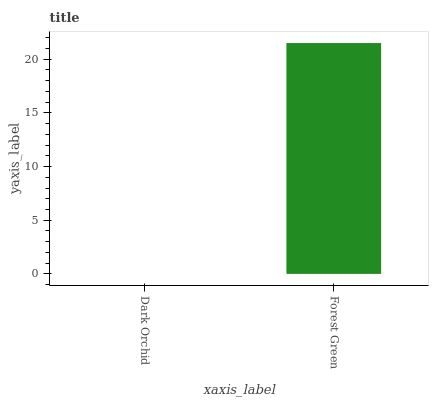Is Dark Orchid the minimum?
Answer yes or no. Yes. Is Forest Green the maximum?
Answer yes or no. Yes. Is Forest Green the minimum?
Answer yes or no. No. Is Forest Green greater than Dark Orchid?
Answer yes or no. Yes. Is Dark Orchid less than Forest Green?
Answer yes or no. Yes. Is Dark Orchid greater than Forest Green?
Answer yes or no. No. Is Forest Green less than Dark Orchid?
Answer yes or no. No. Is Forest Green the high median?
Answer yes or no. Yes. Is Dark Orchid the low median?
Answer yes or no. Yes. Is Dark Orchid the high median?
Answer yes or no. No. Is Forest Green the low median?
Answer yes or no. No. 